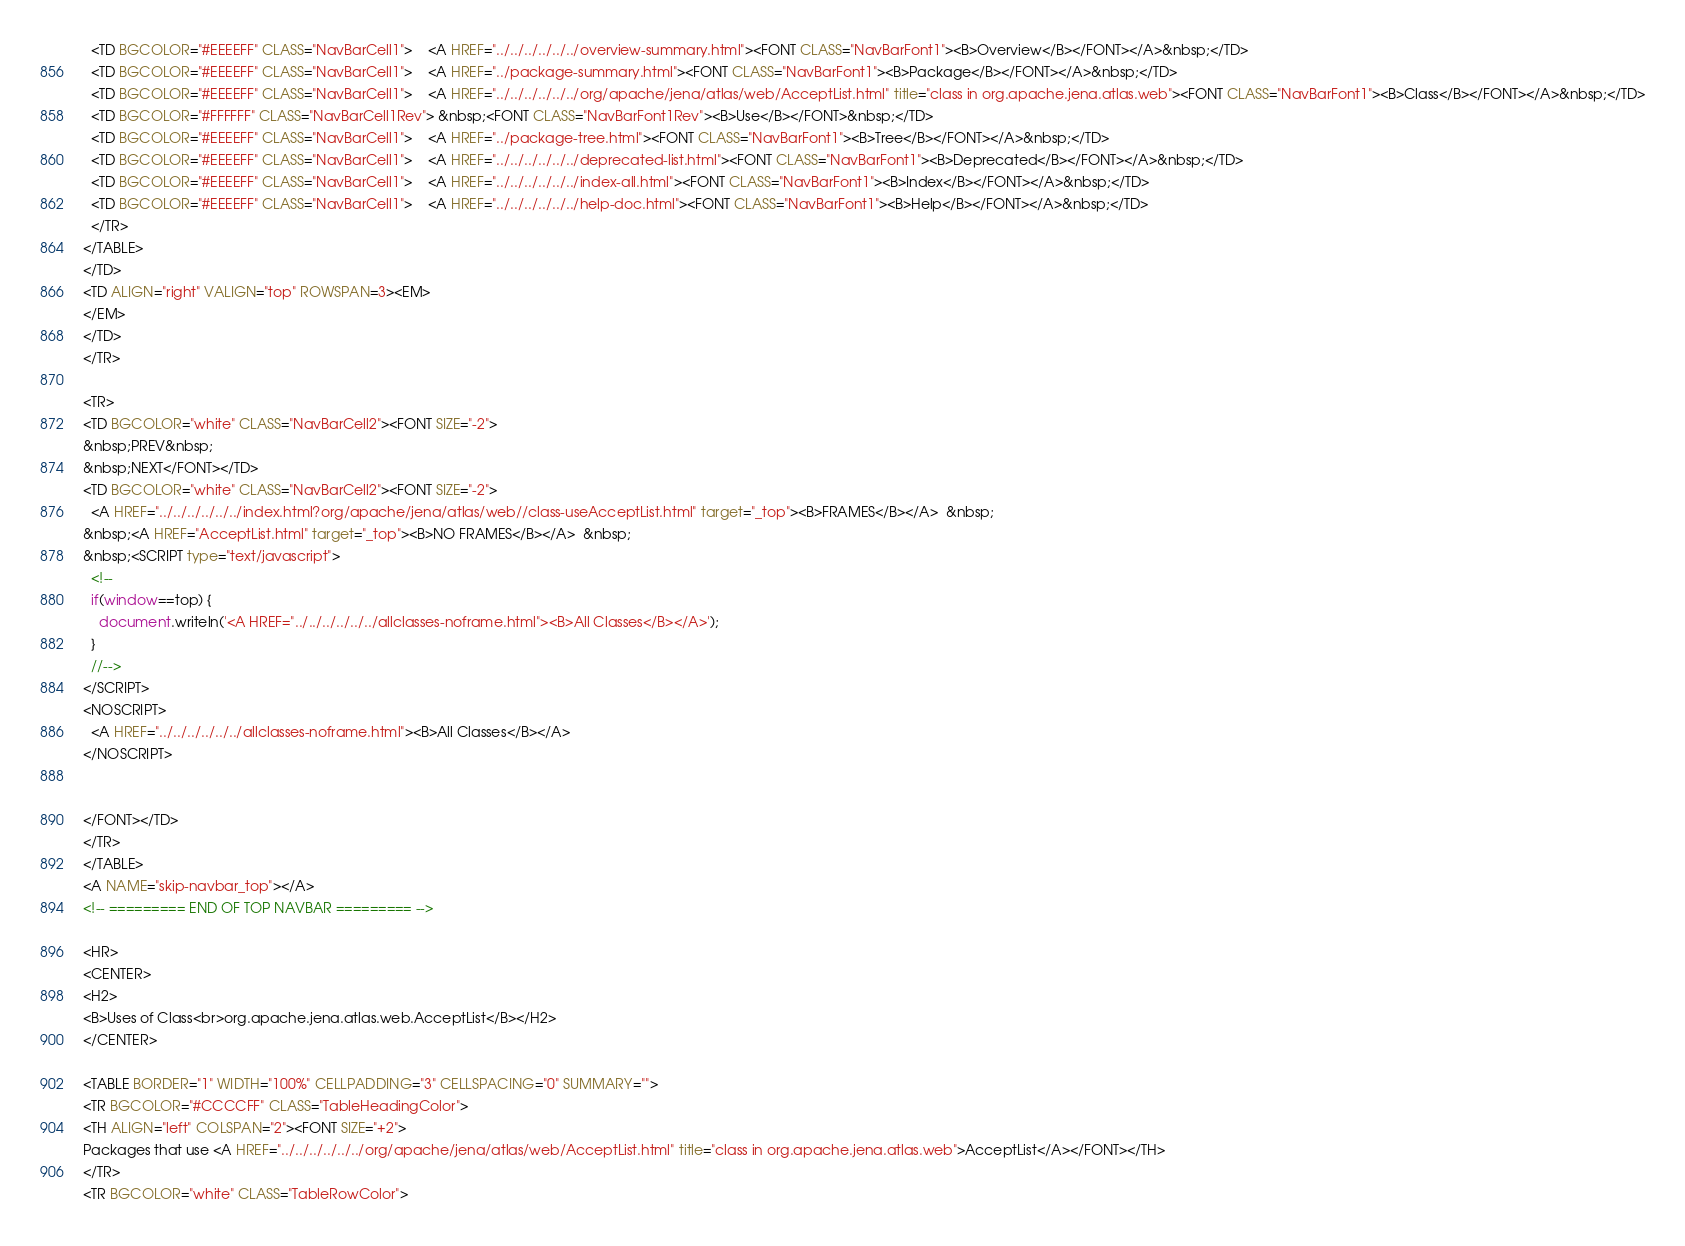Convert code to text. <code><loc_0><loc_0><loc_500><loc_500><_HTML_>  <TD BGCOLOR="#EEEEFF" CLASS="NavBarCell1">    <A HREF="../../../../../../overview-summary.html"><FONT CLASS="NavBarFont1"><B>Overview</B></FONT></A>&nbsp;</TD>
  <TD BGCOLOR="#EEEEFF" CLASS="NavBarCell1">    <A HREF="../package-summary.html"><FONT CLASS="NavBarFont1"><B>Package</B></FONT></A>&nbsp;</TD>
  <TD BGCOLOR="#EEEEFF" CLASS="NavBarCell1">    <A HREF="../../../../../../org/apache/jena/atlas/web/AcceptList.html" title="class in org.apache.jena.atlas.web"><FONT CLASS="NavBarFont1"><B>Class</B></FONT></A>&nbsp;</TD>
  <TD BGCOLOR="#FFFFFF" CLASS="NavBarCell1Rev"> &nbsp;<FONT CLASS="NavBarFont1Rev"><B>Use</B></FONT>&nbsp;</TD>
  <TD BGCOLOR="#EEEEFF" CLASS="NavBarCell1">    <A HREF="../package-tree.html"><FONT CLASS="NavBarFont1"><B>Tree</B></FONT></A>&nbsp;</TD>
  <TD BGCOLOR="#EEEEFF" CLASS="NavBarCell1">    <A HREF="../../../../../../deprecated-list.html"><FONT CLASS="NavBarFont1"><B>Deprecated</B></FONT></A>&nbsp;</TD>
  <TD BGCOLOR="#EEEEFF" CLASS="NavBarCell1">    <A HREF="../../../../../../index-all.html"><FONT CLASS="NavBarFont1"><B>Index</B></FONT></A>&nbsp;</TD>
  <TD BGCOLOR="#EEEEFF" CLASS="NavBarCell1">    <A HREF="../../../../../../help-doc.html"><FONT CLASS="NavBarFont1"><B>Help</B></FONT></A>&nbsp;</TD>
  </TR>
</TABLE>
</TD>
<TD ALIGN="right" VALIGN="top" ROWSPAN=3><EM>
</EM>
</TD>
</TR>

<TR>
<TD BGCOLOR="white" CLASS="NavBarCell2"><FONT SIZE="-2">
&nbsp;PREV&nbsp;
&nbsp;NEXT</FONT></TD>
<TD BGCOLOR="white" CLASS="NavBarCell2"><FONT SIZE="-2">
  <A HREF="../../../../../../index.html?org/apache/jena/atlas/web//class-useAcceptList.html" target="_top"><B>FRAMES</B></A>  &nbsp;
&nbsp;<A HREF="AcceptList.html" target="_top"><B>NO FRAMES</B></A>  &nbsp;
&nbsp;<SCRIPT type="text/javascript">
  <!--
  if(window==top) {
    document.writeln('<A HREF="../../../../../../allclasses-noframe.html"><B>All Classes</B></A>');
  }
  //-->
</SCRIPT>
<NOSCRIPT>
  <A HREF="../../../../../../allclasses-noframe.html"><B>All Classes</B></A>
</NOSCRIPT>


</FONT></TD>
</TR>
</TABLE>
<A NAME="skip-navbar_top"></A>
<!-- ========= END OF TOP NAVBAR ========= -->

<HR>
<CENTER>
<H2>
<B>Uses of Class<br>org.apache.jena.atlas.web.AcceptList</B></H2>
</CENTER>

<TABLE BORDER="1" WIDTH="100%" CELLPADDING="3" CELLSPACING="0" SUMMARY="">
<TR BGCOLOR="#CCCCFF" CLASS="TableHeadingColor">
<TH ALIGN="left" COLSPAN="2"><FONT SIZE="+2">
Packages that use <A HREF="../../../../../../org/apache/jena/atlas/web/AcceptList.html" title="class in org.apache.jena.atlas.web">AcceptList</A></FONT></TH>
</TR>
<TR BGCOLOR="white" CLASS="TableRowColor"></code> 